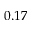<formula> <loc_0><loc_0><loc_500><loc_500>0 . 1 7</formula> 